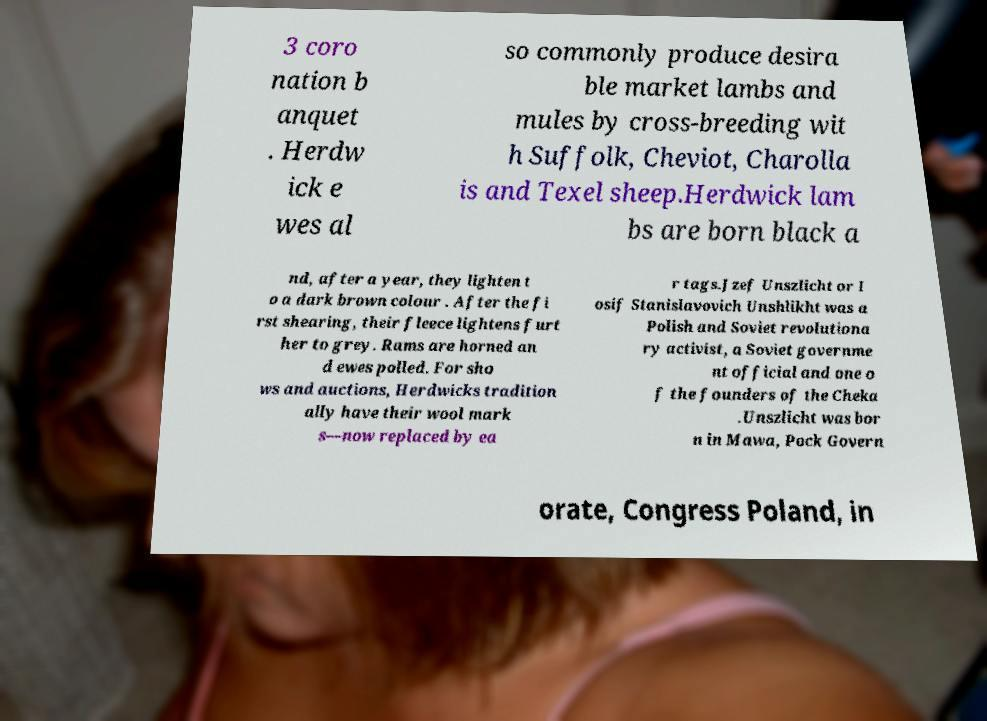Can you accurately transcribe the text from the provided image for me? 3 coro nation b anquet . Herdw ick e wes al so commonly produce desira ble market lambs and mules by cross-breeding wit h Suffolk, Cheviot, Charolla is and Texel sheep.Herdwick lam bs are born black a nd, after a year, they lighten t o a dark brown colour . After the fi rst shearing, their fleece lightens furt her to grey. Rams are horned an d ewes polled. For sho ws and auctions, Herdwicks tradition ally have their wool mark s—now replaced by ea r tags.Jzef Unszlicht or I osif Stanislavovich Unshlikht was a Polish and Soviet revolutiona ry activist, a Soviet governme nt official and one o f the founders of the Cheka .Unszlicht was bor n in Mawa, Pock Govern orate, Congress Poland, in 